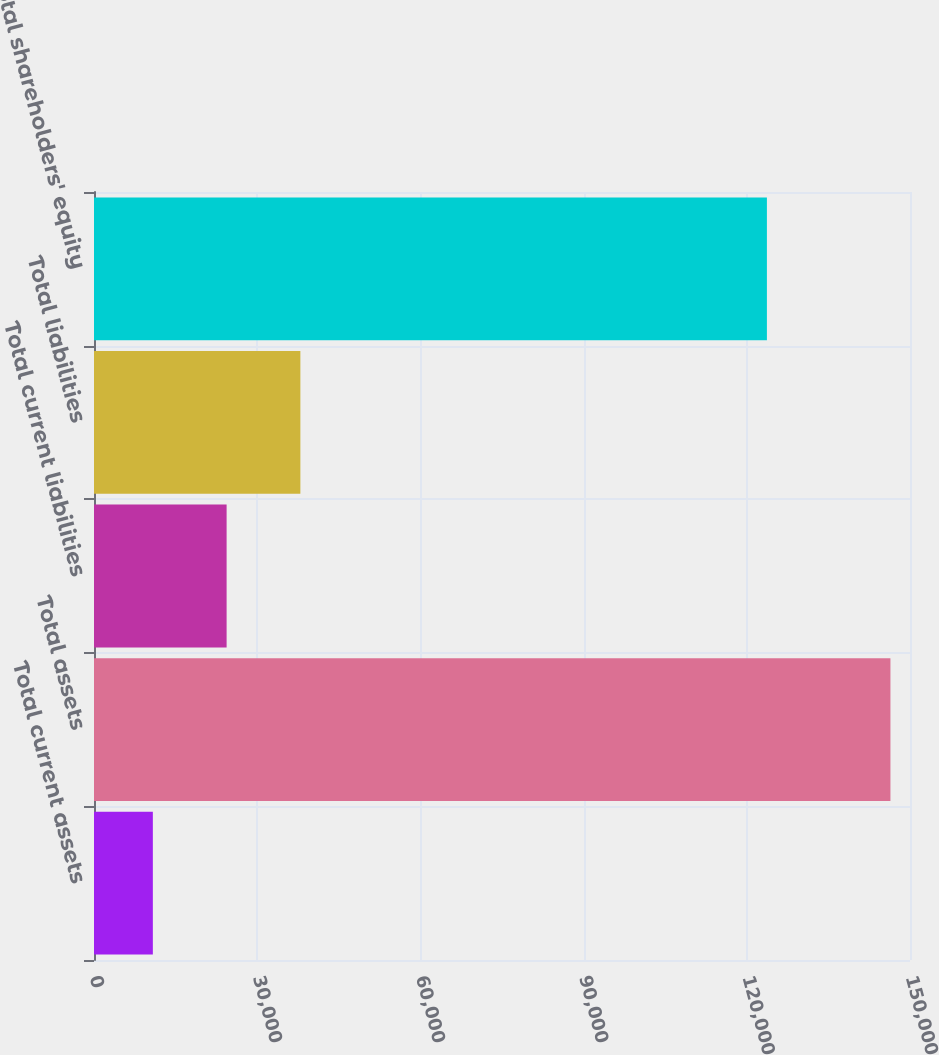Convert chart to OTSL. <chart><loc_0><loc_0><loc_500><loc_500><bar_chart><fcel>Total current assets<fcel>Total assets<fcel>Total current liabilities<fcel>Total liabilities<fcel>Total shareholders' equity<nl><fcel>10819<fcel>146403<fcel>24377.4<fcel>37935.8<fcel>123697<nl></chart> 